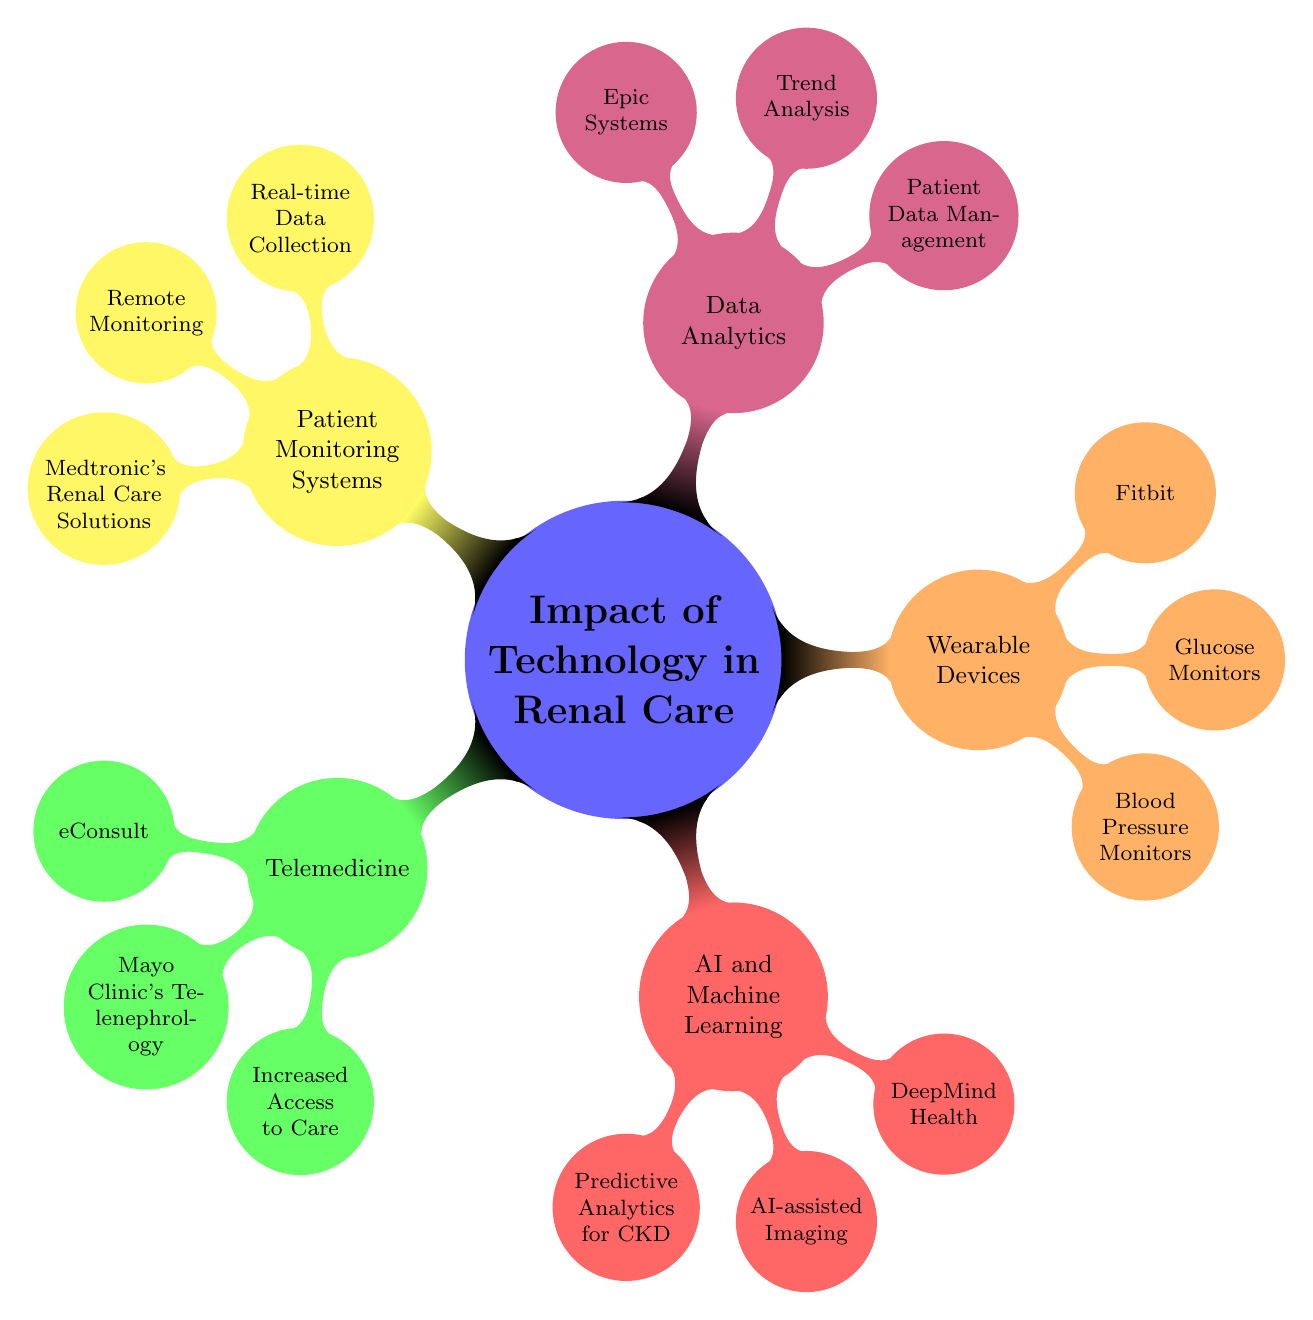What are two initiatives under Telemedicine? The diagram indicates that under the Telemedicine branch, two specific initiatives are listed: eConsult and Mayo Clinic's Telenephrology.
Answer: eConsult, Mayo Clinic's Telenephrology What is one benefit of Telemedicine? Looking at the benefits section under Telemedicine, it lists three benefits, one of which is Increased Access to Care.
Answer: Increased Access to Care Which company is associated with AI and Machine Learning in Renal Care? The diagram shows that one company under the AI and Machine Learning branch is DeepMind Health, highlighting its role in the industry.
Answer: DeepMind Health How many types of Wearable Devices are mentioned? In the Wearable Devices section, three specific types are enumerated: Blood Pressure Monitors, Glucose Monitors, and Smart Watches, leading to the total count of three types.
Answer: 3 What does the Patient Monitoring Systems feature Real-time Data Collection indicate? The feature Real-time Data Collection is explicitly listed under the Patient Monitoring Systems, indicating its importance in providing timely data for renal care management.
Answer: Real-time Data Collection What is the primary use of Data Analytics in Renal Care? The diagram shows that Patient Data Management is one of the primary uses of Data Analytics, signifying its critical role in managing patient information.
Answer: Patient Data Management How many companies are listed under AI and Machine Learning? Under the AI and Machine Learning branch, there are two companies mentioned: DeepMind Health and IBM Watson Health, hence the total count is two.
Answer: 2 What are the types of Wearable Devices mentioned? The Your types of Wearable Devices are specifically Blood Pressure Monitors, Glucose Monitors, and Smart Watches according to the Wearable Devices section of the mind map.
Answer: Blood Pressure Monitors, Glucose Monitors, Smart Watches What feature is associated with Patient Monitoring Systems? Among the features listed under Patient Monitoring Systems, Remote Monitoring is explicitly mentioned, indicating it is an essential aspect of modern renal care.
Answer: Remote Monitoring 